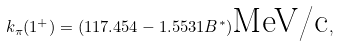<formula> <loc_0><loc_0><loc_500><loc_500>k _ { \pi } ( 1 ^ { + } ) = ( 1 1 7 . 4 5 4 - 1 . 5 5 3 1 B ^ { * } ) \text {MeV/c} ,</formula> 